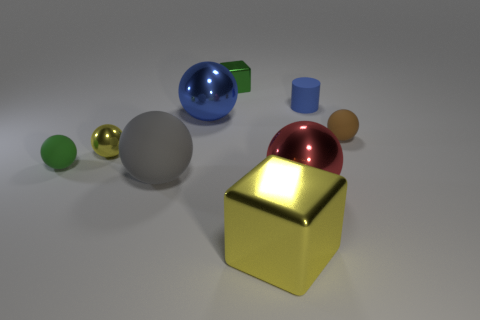Subtract all brown spheres. How many spheres are left? 5 Subtract all gray matte spheres. How many spheres are left? 5 Subtract all red spheres. Subtract all yellow blocks. How many spheres are left? 5 Subtract all cubes. How many objects are left? 7 Subtract 1 brown balls. How many objects are left? 8 Subtract all large brown shiny cylinders. Subtract all metal objects. How many objects are left? 4 Add 7 tiny brown rubber things. How many tiny brown rubber things are left? 8 Add 5 big yellow blocks. How many big yellow blocks exist? 6 